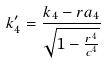Convert formula to latex. <formula><loc_0><loc_0><loc_500><loc_500>k _ { 4 } ^ { \prime } = \frac { k _ { 4 } - r a _ { 4 } } { \sqrt { 1 - \frac { r ^ { 4 } } { c ^ { 4 } } } }</formula> 